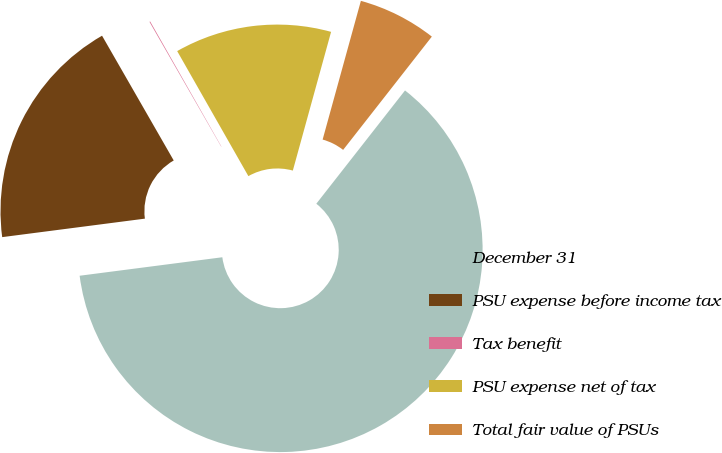Convert chart. <chart><loc_0><loc_0><loc_500><loc_500><pie_chart><fcel>December 31<fcel>PSU expense before income tax<fcel>Tax benefit<fcel>PSU expense net of tax<fcel>Total fair value of PSUs<nl><fcel>62.37%<fcel>18.75%<fcel>0.06%<fcel>12.52%<fcel>6.29%<nl></chart> 